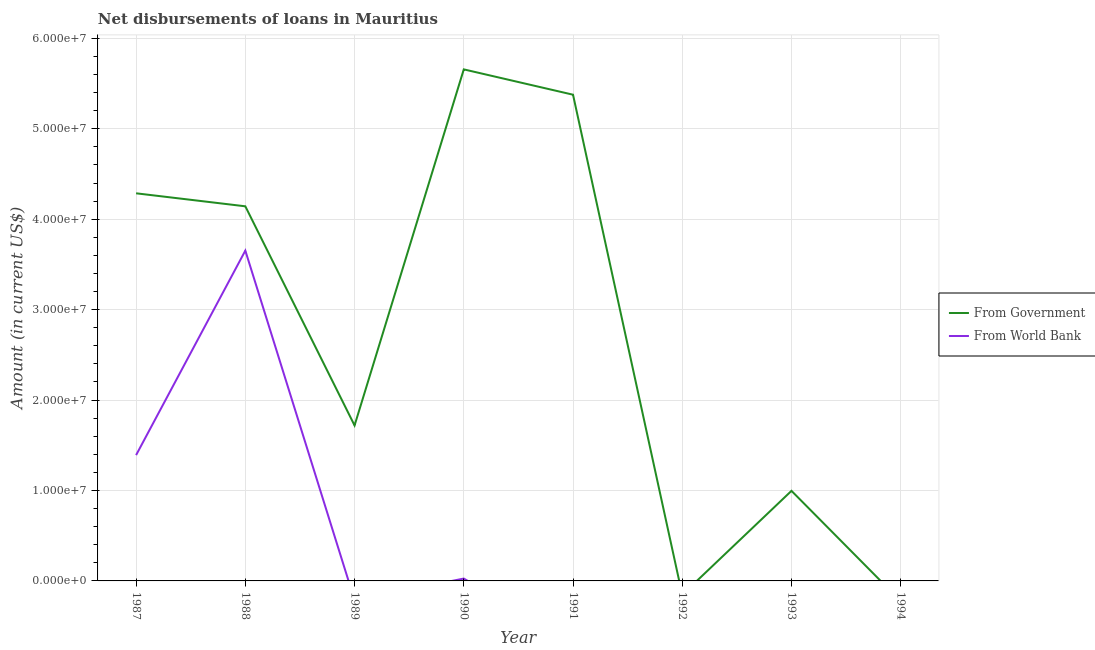Does the line corresponding to net disbursements of loan from world bank intersect with the line corresponding to net disbursements of loan from government?
Make the answer very short. No. Across all years, what is the maximum net disbursements of loan from world bank?
Your answer should be compact. 3.65e+07. What is the total net disbursements of loan from world bank in the graph?
Provide a short and direct response. 5.07e+07. What is the difference between the net disbursements of loan from government in 1988 and that in 1991?
Provide a short and direct response. -1.23e+07. What is the difference between the net disbursements of loan from world bank in 1990 and the net disbursements of loan from government in 1992?
Make the answer very short. 2.60e+05. What is the average net disbursements of loan from government per year?
Your answer should be compact. 2.77e+07. In the year 1990, what is the difference between the net disbursements of loan from government and net disbursements of loan from world bank?
Your response must be concise. 5.63e+07. In how many years, is the net disbursements of loan from government greater than 6000000 US$?
Provide a succinct answer. 6. What is the ratio of the net disbursements of loan from world bank in 1987 to that in 1990?
Keep it short and to the point. 53.51. What is the difference between the highest and the second highest net disbursements of loan from government?
Offer a terse response. 2.80e+06. What is the difference between the highest and the lowest net disbursements of loan from government?
Keep it short and to the point. 5.66e+07. In how many years, is the net disbursements of loan from world bank greater than the average net disbursements of loan from world bank taken over all years?
Your answer should be very brief. 2. Is the net disbursements of loan from world bank strictly greater than the net disbursements of loan from government over the years?
Your response must be concise. No. How many lines are there?
Offer a very short reply. 2. How many years are there in the graph?
Your answer should be very brief. 8. What is the difference between two consecutive major ticks on the Y-axis?
Keep it short and to the point. 1.00e+07. Does the graph contain any zero values?
Provide a succinct answer. Yes. Does the graph contain grids?
Your answer should be compact. Yes. What is the title of the graph?
Your answer should be compact. Net disbursements of loans in Mauritius. Does "Resident workers" appear as one of the legend labels in the graph?
Keep it short and to the point. No. What is the Amount (in current US$) in From Government in 1987?
Provide a short and direct response. 4.29e+07. What is the Amount (in current US$) of From World Bank in 1987?
Give a very brief answer. 1.39e+07. What is the Amount (in current US$) of From Government in 1988?
Your answer should be very brief. 4.14e+07. What is the Amount (in current US$) in From World Bank in 1988?
Keep it short and to the point. 3.65e+07. What is the Amount (in current US$) of From Government in 1989?
Provide a succinct answer. 1.72e+07. What is the Amount (in current US$) of From Government in 1990?
Keep it short and to the point. 5.66e+07. What is the Amount (in current US$) in From World Bank in 1990?
Keep it short and to the point. 2.60e+05. What is the Amount (in current US$) in From Government in 1991?
Your answer should be very brief. 5.38e+07. What is the Amount (in current US$) in From World Bank in 1991?
Make the answer very short. 0. What is the Amount (in current US$) of From Government in 1993?
Make the answer very short. 9.96e+06. Across all years, what is the maximum Amount (in current US$) of From Government?
Give a very brief answer. 5.66e+07. Across all years, what is the maximum Amount (in current US$) of From World Bank?
Give a very brief answer. 3.65e+07. Across all years, what is the minimum Amount (in current US$) of From Government?
Make the answer very short. 0. What is the total Amount (in current US$) of From Government in the graph?
Provide a short and direct response. 2.22e+08. What is the total Amount (in current US$) in From World Bank in the graph?
Your response must be concise. 5.07e+07. What is the difference between the Amount (in current US$) of From Government in 1987 and that in 1988?
Provide a short and direct response. 1.44e+06. What is the difference between the Amount (in current US$) of From World Bank in 1987 and that in 1988?
Make the answer very short. -2.26e+07. What is the difference between the Amount (in current US$) of From Government in 1987 and that in 1989?
Offer a terse response. 2.57e+07. What is the difference between the Amount (in current US$) in From Government in 1987 and that in 1990?
Your response must be concise. -1.37e+07. What is the difference between the Amount (in current US$) in From World Bank in 1987 and that in 1990?
Offer a very short reply. 1.37e+07. What is the difference between the Amount (in current US$) of From Government in 1987 and that in 1991?
Provide a short and direct response. -1.09e+07. What is the difference between the Amount (in current US$) in From Government in 1987 and that in 1993?
Ensure brevity in your answer.  3.29e+07. What is the difference between the Amount (in current US$) in From Government in 1988 and that in 1989?
Your answer should be very brief. 2.42e+07. What is the difference between the Amount (in current US$) of From Government in 1988 and that in 1990?
Ensure brevity in your answer.  -1.51e+07. What is the difference between the Amount (in current US$) in From World Bank in 1988 and that in 1990?
Offer a very short reply. 3.63e+07. What is the difference between the Amount (in current US$) in From Government in 1988 and that in 1991?
Your response must be concise. -1.23e+07. What is the difference between the Amount (in current US$) in From Government in 1988 and that in 1993?
Give a very brief answer. 3.15e+07. What is the difference between the Amount (in current US$) in From Government in 1989 and that in 1990?
Ensure brevity in your answer.  -3.94e+07. What is the difference between the Amount (in current US$) of From Government in 1989 and that in 1991?
Your response must be concise. -3.66e+07. What is the difference between the Amount (in current US$) in From Government in 1989 and that in 1993?
Offer a terse response. 7.23e+06. What is the difference between the Amount (in current US$) of From Government in 1990 and that in 1991?
Your response must be concise. 2.80e+06. What is the difference between the Amount (in current US$) in From Government in 1990 and that in 1993?
Make the answer very short. 4.66e+07. What is the difference between the Amount (in current US$) in From Government in 1991 and that in 1993?
Your answer should be very brief. 4.38e+07. What is the difference between the Amount (in current US$) in From Government in 1987 and the Amount (in current US$) in From World Bank in 1988?
Keep it short and to the point. 6.34e+06. What is the difference between the Amount (in current US$) in From Government in 1987 and the Amount (in current US$) in From World Bank in 1990?
Ensure brevity in your answer.  4.26e+07. What is the difference between the Amount (in current US$) in From Government in 1988 and the Amount (in current US$) in From World Bank in 1990?
Provide a succinct answer. 4.12e+07. What is the difference between the Amount (in current US$) in From Government in 1989 and the Amount (in current US$) in From World Bank in 1990?
Ensure brevity in your answer.  1.69e+07. What is the average Amount (in current US$) of From Government per year?
Offer a very short reply. 2.77e+07. What is the average Amount (in current US$) of From World Bank per year?
Keep it short and to the point. 6.34e+06. In the year 1987, what is the difference between the Amount (in current US$) of From Government and Amount (in current US$) of From World Bank?
Make the answer very short. 2.89e+07. In the year 1988, what is the difference between the Amount (in current US$) in From Government and Amount (in current US$) in From World Bank?
Provide a short and direct response. 4.90e+06. In the year 1990, what is the difference between the Amount (in current US$) of From Government and Amount (in current US$) of From World Bank?
Make the answer very short. 5.63e+07. What is the ratio of the Amount (in current US$) of From Government in 1987 to that in 1988?
Provide a succinct answer. 1.03. What is the ratio of the Amount (in current US$) of From World Bank in 1987 to that in 1988?
Your answer should be compact. 0.38. What is the ratio of the Amount (in current US$) in From Government in 1987 to that in 1989?
Keep it short and to the point. 2.49. What is the ratio of the Amount (in current US$) in From Government in 1987 to that in 1990?
Offer a very short reply. 0.76. What is the ratio of the Amount (in current US$) in From World Bank in 1987 to that in 1990?
Make the answer very short. 53.51. What is the ratio of the Amount (in current US$) of From Government in 1987 to that in 1991?
Make the answer very short. 0.8. What is the ratio of the Amount (in current US$) of From Government in 1987 to that in 1993?
Your response must be concise. 4.3. What is the ratio of the Amount (in current US$) in From Government in 1988 to that in 1989?
Give a very brief answer. 2.41. What is the ratio of the Amount (in current US$) of From Government in 1988 to that in 1990?
Give a very brief answer. 0.73. What is the ratio of the Amount (in current US$) in From World Bank in 1988 to that in 1990?
Provide a short and direct response. 140.48. What is the ratio of the Amount (in current US$) in From Government in 1988 to that in 1991?
Your answer should be very brief. 0.77. What is the ratio of the Amount (in current US$) of From Government in 1988 to that in 1993?
Ensure brevity in your answer.  4.16. What is the ratio of the Amount (in current US$) in From Government in 1989 to that in 1990?
Offer a terse response. 0.3. What is the ratio of the Amount (in current US$) in From Government in 1989 to that in 1991?
Your answer should be compact. 0.32. What is the ratio of the Amount (in current US$) in From Government in 1989 to that in 1993?
Your response must be concise. 1.73. What is the ratio of the Amount (in current US$) in From Government in 1990 to that in 1991?
Offer a very short reply. 1.05. What is the ratio of the Amount (in current US$) in From Government in 1990 to that in 1993?
Your answer should be very brief. 5.68. What is the ratio of the Amount (in current US$) in From Government in 1991 to that in 1993?
Offer a terse response. 5.4. What is the difference between the highest and the second highest Amount (in current US$) of From Government?
Your answer should be compact. 2.80e+06. What is the difference between the highest and the second highest Amount (in current US$) in From World Bank?
Ensure brevity in your answer.  2.26e+07. What is the difference between the highest and the lowest Amount (in current US$) in From Government?
Your response must be concise. 5.66e+07. What is the difference between the highest and the lowest Amount (in current US$) of From World Bank?
Offer a very short reply. 3.65e+07. 